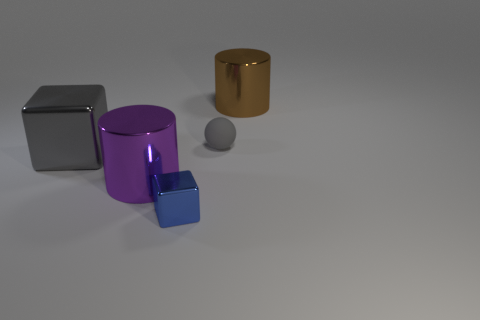Add 5 large cyan objects. How many objects exist? 10 Subtract 1 spheres. How many spheres are left? 0 Subtract all brown cylinders. How many cylinders are left? 1 Subtract all blue cylinders. Subtract all green balls. How many cylinders are left? 2 Subtract all yellow cylinders. How many green balls are left? 0 Subtract all purple shiny cylinders. Subtract all tiny objects. How many objects are left? 2 Add 3 gray balls. How many gray balls are left? 4 Add 1 red metal cubes. How many red metal cubes exist? 1 Subtract 0 yellow blocks. How many objects are left? 5 Subtract all spheres. How many objects are left? 4 